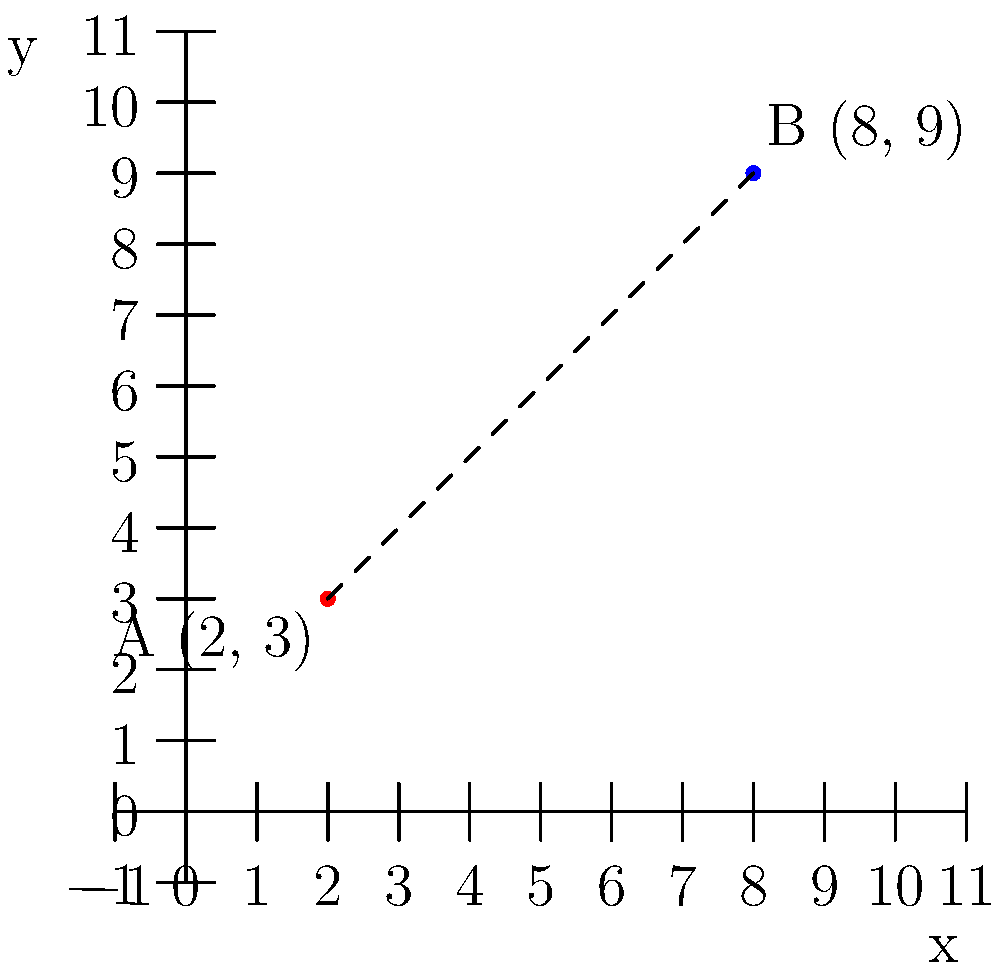In a recovery journey, point A (2, 3) represents the initial milestone of starting physical therapy, and point B (8, 9) represents achieving independent mobility. Calculate the distance between these two milestones on the recovery journey coordinate plane. To find the distance between two points on a coordinate plane, we can use the distance formula:

$$d = \sqrt{(x_2 - x_1)^2 + (y_2 - y_1)^2}$$

Where $(x_1, y_1)$ is the first point and $(x_2, y_2)$ is the second point.

Step 1: Identify the coordinates
Point A: $(x_1, y_1) = (2, 3)$
Point B: $(x_2, y_2) = (8, 9)$

Step 2: Substitute the values into the distance formula
$$d = \sqrt{(8 - 2)^2 + (9 - 3)^2}$$

Step 3: Simplify the expressions inside the parentheses
$$d = \sqrt{6^2 + 6^2}$$

Step 4: Calculate the squares
$$d = \sqrt{36 + 36}$$

Step 5: Add the values under the square root
$$d = \sqrt{72}$$

Step 6: Simplify the square root
$$d = 6\sqrt{2}$$

Therefore, the distance between the two milestones on the recovery journey is $6\sqrt{2}$ units.
Answer: $6\sqrt{2}$ units 